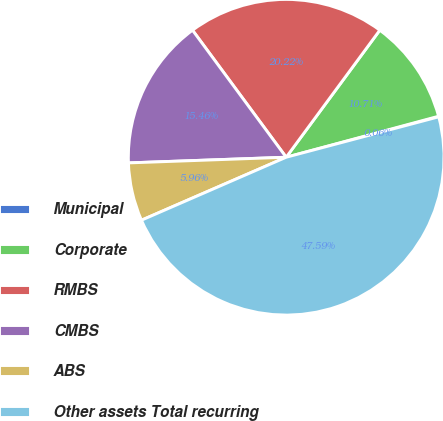Convert chart. <chart><loc_0><loc_0><loc_500><loc_500><pie_chart><fcel>Municipal<fcel>Corporate<fcel>RMBS<fcel>CMBS<fcel>ABS<fcel>Other assets Total recurring<nl><fcel>0.06%<fcel>10.71%<fcel>20.22%<fcel>15.46%<fcel>5.96%<fcel>47.59%<nl></chart> 